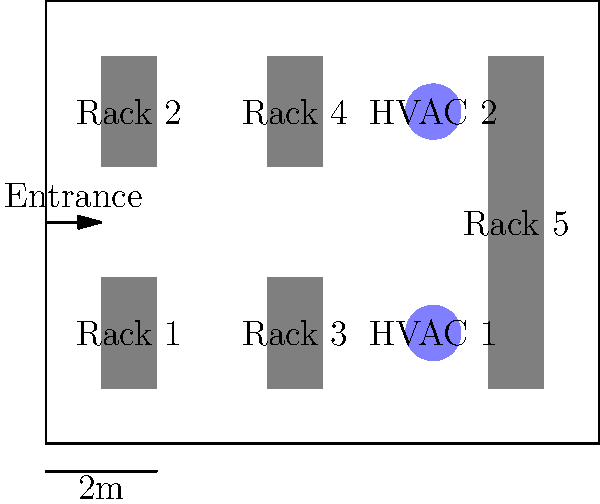Based on the server room layout shown in the diagram, what would be the most effective way to optimize airflow and cooling efficiency? Consider the placement of racks and HVAC units. To optimize airflow and cooling efficiency in the server room, we need to consider the following steps:

1. Analyze the current layout:
   - 5 server racks are present (Racks 1-5)
   - 2 HVAC units are located on the right side of the room
   - The entrance is on the left side

2. Identify the hot aisle/cold aisle configuration:
   - Currently, there's no clear separation between hot and cold aisles
   - Racks 1-4 are arranged in a way that could create a hot aisle in the middle

3. Optimize rack placement:
   - Rotate Racks 1-4 to face the same direction
   - Create a clear cold aisle in front of the racks and a hot aisle behind them

4. Improve HVAC placement:
   - Move HVAC units closer to the hot aisle to efficiently remove hot air
   - Ensure cold air is directed towards the front of the racks

5. Manage cable placement:
   - Ensure cables are organized and don't obstruct airflow under raised floors or above racks

6. Implement containment solutions:
   - Add containment barriers to separate hot and cold aisles
   - This prevents mixing of hot and cold air, improving cooling efficiency

7. Monitor and adjust:
   - Implement temperature and airflow monitoring systems
   - Make adjustments based on real-time data to maintain optimal conditions

The most effective optimization would be to implement a hot aisle/cold aisle configuration by rotating Racks 1-4, moving HVAC units closer to the hot aisle, and adding containment barriers.
Answer: Implement hot aisle/cold aisle configuration with containment barriers 